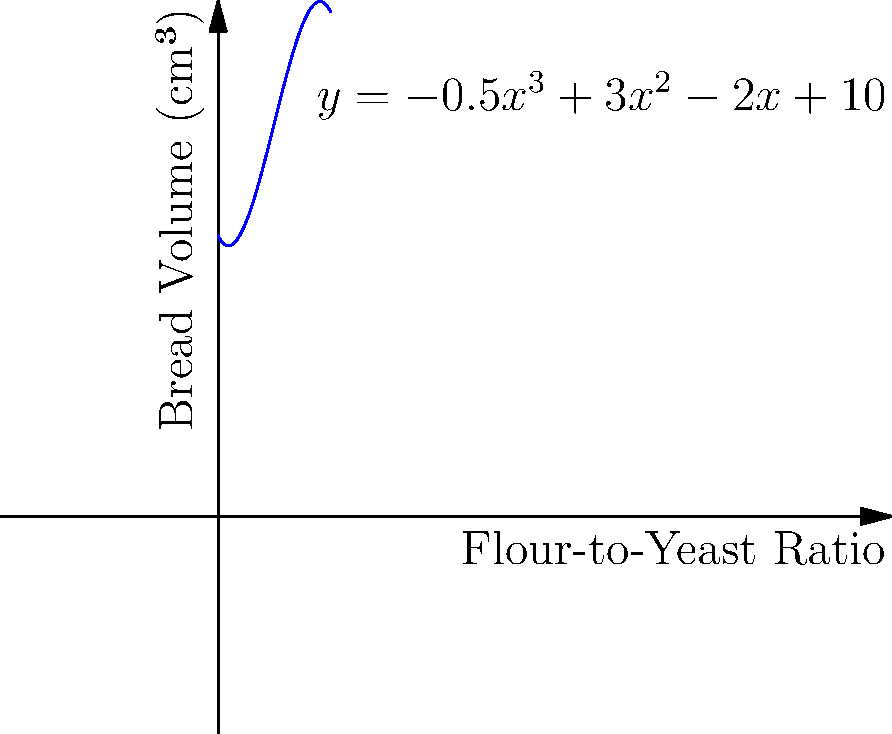The graph represents the relationship between the flour-to-yeast ratio and bread volume expansion in your artisanal bakery. The polynomial function is given by $y = -0.5x^3 + 3x^2 - 2x + 10$, where $x$ is the flour-to-yeast ratio and $y$ is the bread volume in cubic centimeters. At which flour-to-yeast ratio does the bread achieve its maximum volume? To find the maximum volume, we need to determine where the derivative of the function equals zero:

1) First, calculate the derivative:
   $f'(x) = -1.5x^2 + 6x - 2$

2) Set the derivative equal to zero and solve:
   $-1.5x^2 + 6x - 2 = 0$

3) This is a quadratic equation. We can solve it using the quadratic formula:
   $x = \frac{-b \pm \sqrt{b^2 - 4ac}}{2a}$

   Where $a = -1.5$, $b = 6$, and $c = -2$

4) Plugging in these values:
   $x = \frac{-6 \pm \sqrt{36 - 4(-1.5)(-2)}}{2(-1.5)}$
   $= \frac{-6 \pm \sqrt{36 - 12}}{-3}$
   $= \frac{-6 \pm \sqrt{24}}{-3}$
   $= \frac{-6 \pm 2\sqrt{6}}{-3}$

5) This gives us two solutions:
   $x_1 = \frac{-6 + 2\sqrt{6}}{-3} = 2 - \frac{2\sqrt{6}}{3}$
   $x_2 = \frac{-6 - 2\sqrt{6}}{-3} = 2 + \frac{2\sqrt{6}}{3}$

6) To determine which solution gives the maximum (rather than minimum), we can check the second derivative:
   $f''(x) = -3x + 6$

7) At $x = 2 + \frac{2\sqrt{6}}{3}$, $f''(x) < 0$, indicating this is the maximum point.

Therefore, the bread achieves its maximum volume at a flour-to-yeast ratio of $2 + \frac{2\sqrt{6}}{3}$.
Answer: $2 + \frac{2\sqrt{6}}{3}$ 